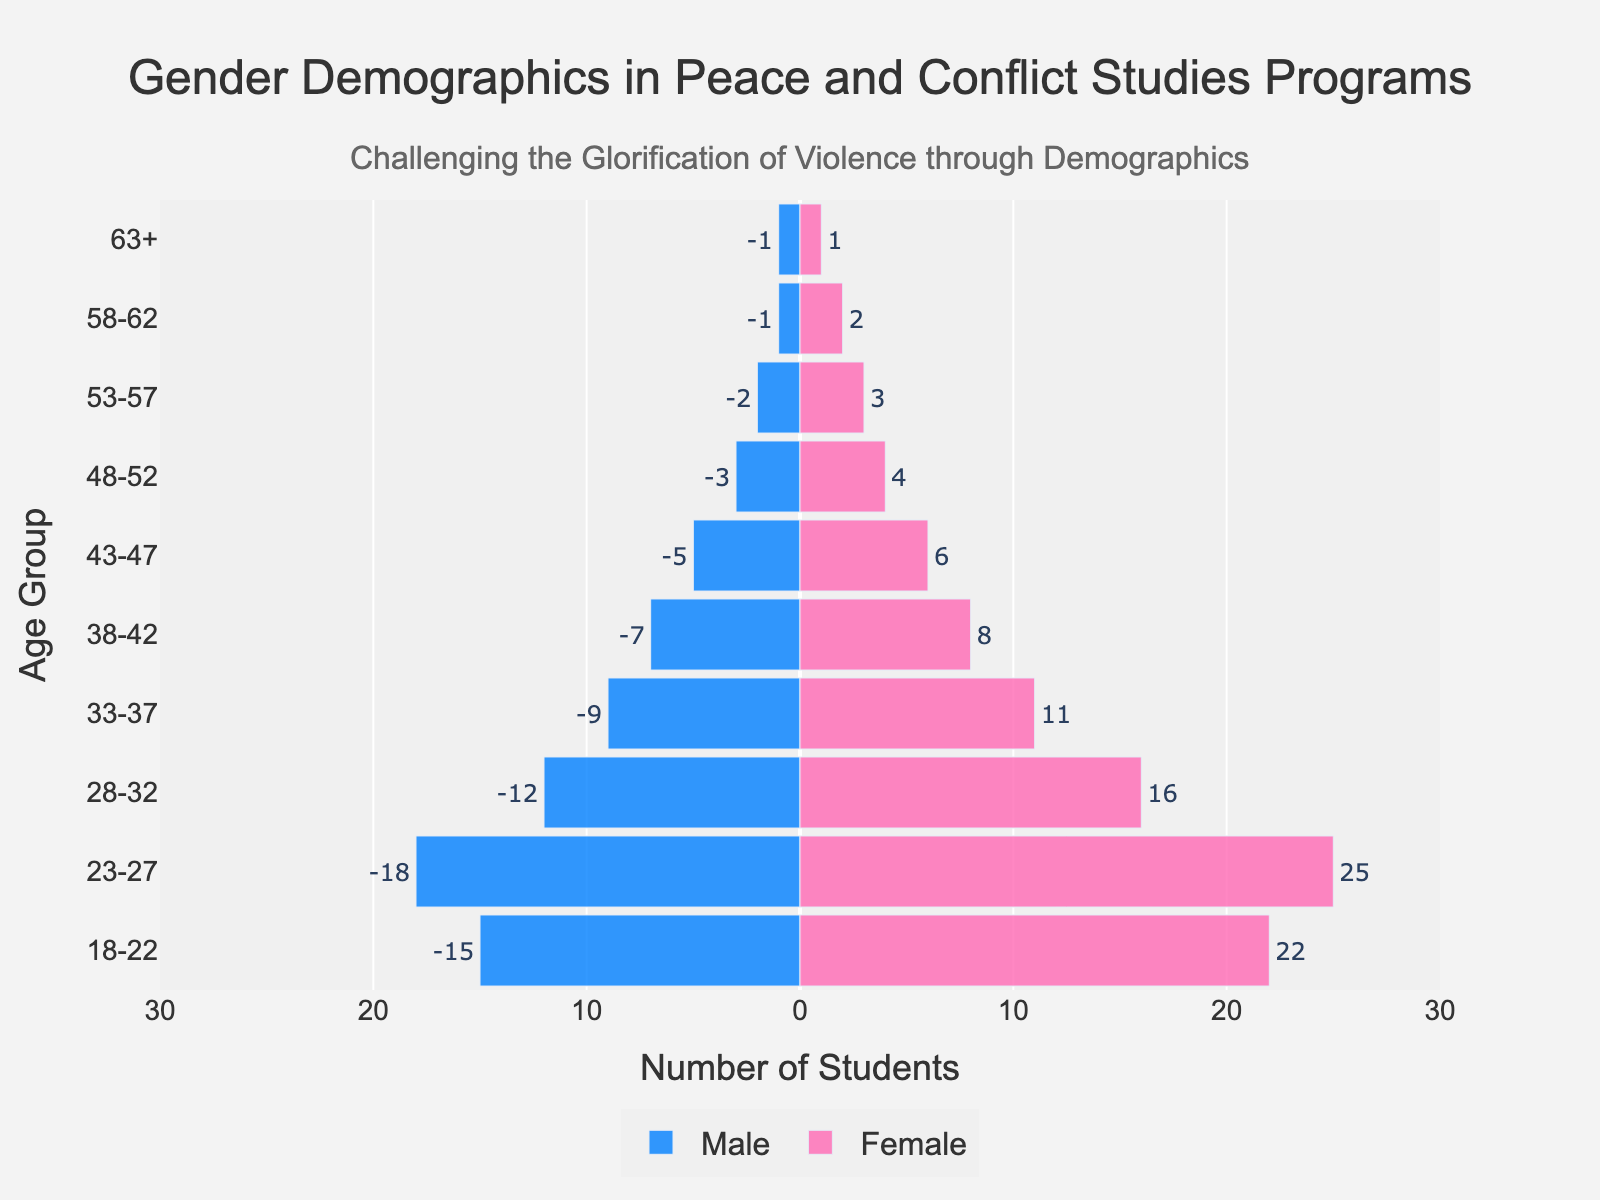What is the age group with the most students enrolled in peace and conflict studies programs? The age group with the most students will have the highest combined bar lengths for both male and female students. Comparing the bars, the age group 23-27 has the highest combined bar lengths.
Answer: 23-27 Which gender has more students in the 18-22 age group? To determine which gender has more students in the 18-22 age group, compare the lengths of the bars for males and females in that age group. The female bar is longer than the male bar.
Answer: Female What is the total number of students in the 33-37 age group? To find the total number of students in the 33-37 age group, add the number of male students (9) to the number of female students (11).
Answer: 20 How many more females than males are there in the 23-27 age group? Subtract the number of males (18) from the number of females (25) in the 23-27 age group.
Answer: 7 What age group has the least number of students enrolled? Identify the age group with the shortest combined bar lengths for both males and females. The 63+ age group has the least number of students with only 2.
Answer: 63+ How does the number of male students in the 28-32 age group compare to female students in the same group? Compare the lengths of the bars for males (12) and females (16) in the 28-32 age group. There are fewer males than females.
Answer: Fewer What is the combined total of male and female students aged 58 and above? Add the number of male and female students in the 58-62 and 63+ age groups: (1+2) + (1+1) = 5.
Answer: 5 What is the ratio of male to female students in the 48-52 age group? The ratio is calculated by dividing the number of males (3) by the number of females (4). Thus, the ratio is 3:4.
Answer: 3:4 In which age group is the gender disparity in enrollment the smallest? To find the smallest gender disparity, compare differences in male and female enrollment in each age group. The 63+ age group has the smallest disparity, with both genders having equal numbers (1 each).
Answer: 63+ What is the average number of students in the 23-27 age group? Add the number of male (18) and female (25) students and divide by 2: (18 + 25) / 2 = 21.5.
Answer: 21.5 